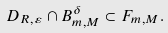Convert formula to latex. <formula><loc_0><loc_0><loc_500><loc_500>D _ { R , \varepsilon } \cap B _ { m , M } ^ { \delta } \subset F _ { m , M } .</formula> 